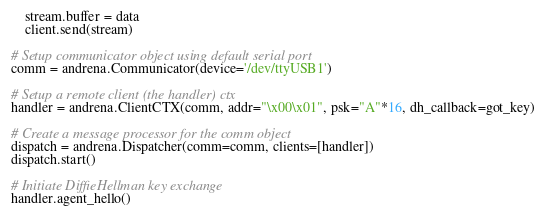<code> <loc_0><loc_0><loc_500><loc_500><_Python_>    stream.buffer = data
    client.send(stream)

# Setup communicator object using default serial port
comm = andrena.Communicator(device='/dev/ttyUSB1')

# Setup a remote client (the handler) ctx
handler = andrena.ClientCTX(comm, addr="\x00\x01", psk="A"*16, dh_callback=got_key)

# Create a message processor for the comm object
dispatch = andrena.Dispatcher(comm=comm, clients=[handler])
dispatch.start()

# Initiate DiffieHellman key exchange
handler.agent_hello()
</code> 